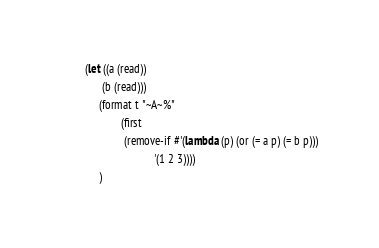<code> <loc_0><loc_0><loc_500><loc_500><_Lisp_>(let ((a (read))
      (b (read)))
     (format t "~A~%"
             (first
              (remove-if #'(lambda (p) (or (= a p) (= b p)))
                         '(1 2 3))))
     )


</code> 